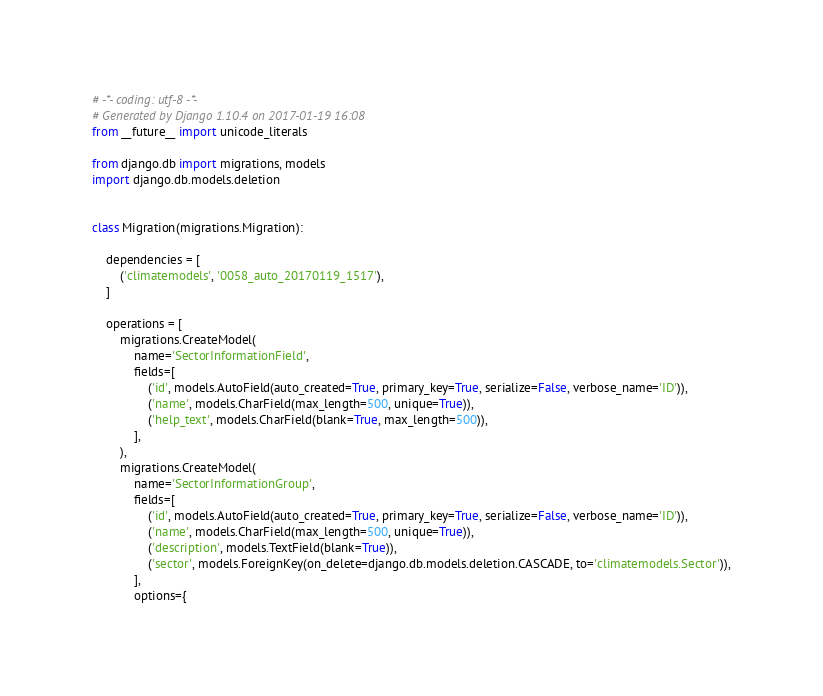<code> <loc_0><loc_0><loc_500><loc_500><_Python_># -*- coding: utf-8 -*-
# Generated by Django 1.10.4 on 2017-01-19 16:08
from __future__ import unicode_literals

from django.db import migrations, models
import django.db.models.deletion


class Migration(migrations.Migration):

    dependencies = [
        ('climatemodels', '0058_auto_20170119_1517'),
    ]

    operations = [
        migrations.CreateModel(
            name='SectorInformationField',
            fields=[
                ('id', models.AutoField(auto_created=True, primary_key=True, serialize=False, verbose_name='ID')),
                ('name', models.CharField(max_length=500, unique=True)),
                ('help_text', models.CharField(blank=True, max_length=500)),
            ],
        ),
        migrations.CreateModel(
            name='SectorInformationGroup',
            fields=[
                ('id', models.AutoField(auto_created=True, primary_key=True, serialize=False, verbose_name='ID')),
                ('name', models.CharField(max_length=500, unique=True)),
                ('description', models.TextField(blank=True)),
                ('sector', models.ForeignKey(on_delete=django.db.models.deletion.CASCADE, to='climatemodels.Sector')),
            ],
            options={</code> 